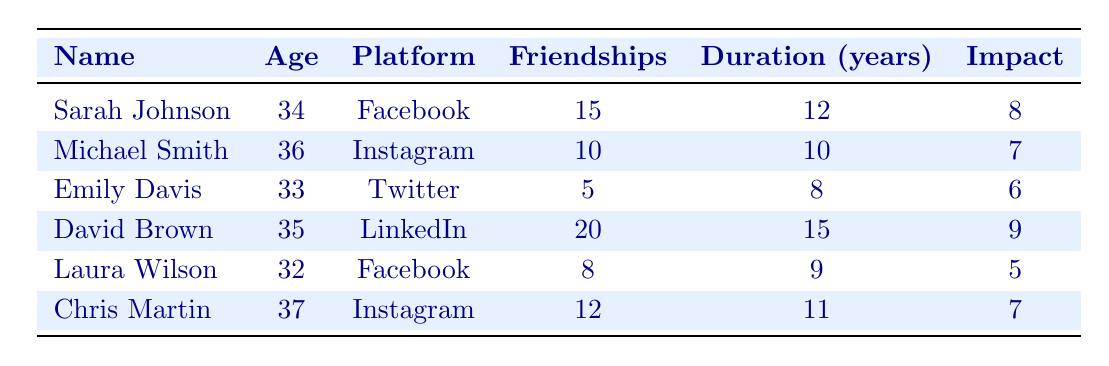What is the age of David Brown? David Brown is listed in the table with an age of 35.
Answer: 35 How many friendships does Sarah Johnson maintain? According to the table, Sarah Johnson maintains 15 friendships.
Answer: 15 Which social media platform has the highest impact rating? By comparing the impact ratings in the table, David Brown on LinkedIn has an impact rating of 9, which is the highest.
Answer: LinkedIn What is the average number of maintained friendships among all respondents? To find the average, add up all maintained friendships: (15 + 10 + 5 + 20 + 8 + 12) = 70. There are 6 respondents, so the average is 70/6 ≈ 11.67.
Answer: 11.67 Is Laura Wilson older than Emily Davis? Laura Wilson is 32 years old, and Emily Davis is 33 years old, making Laura younger than Emily.
Answer: No Which respondent has the longest friendship duration? Comparing the friendship durations, David Brown has been maintaining friendships for 15 years, which is the longest duration listed in the table.
Answer: David Brown What is the total impact rating for all respondents using Instagram? The total impact rating for respondents Michael Smith and Chris Martin, both using Instagram, is 7 + 7 = 14.
Answer: 14 Does the respondent with the highest number of maintained friendships have the highest impact rating? David Brown has the highest number of maintained friendships at 20, but his impact rating is 9, while Sarah Johnson maintains 15 friendships with an impact rating of 8. Therefore, yes; he has the highest friendships and impact rating among respondents.
Answer: Yes What is the difference between the highest and lowest number of maintained friendships? The highest number of maintained friendships is 20 (David Brown), and the lowest is 5 (Emily Davis). The difference is 20 - 5 = 15.
Answer: 15 